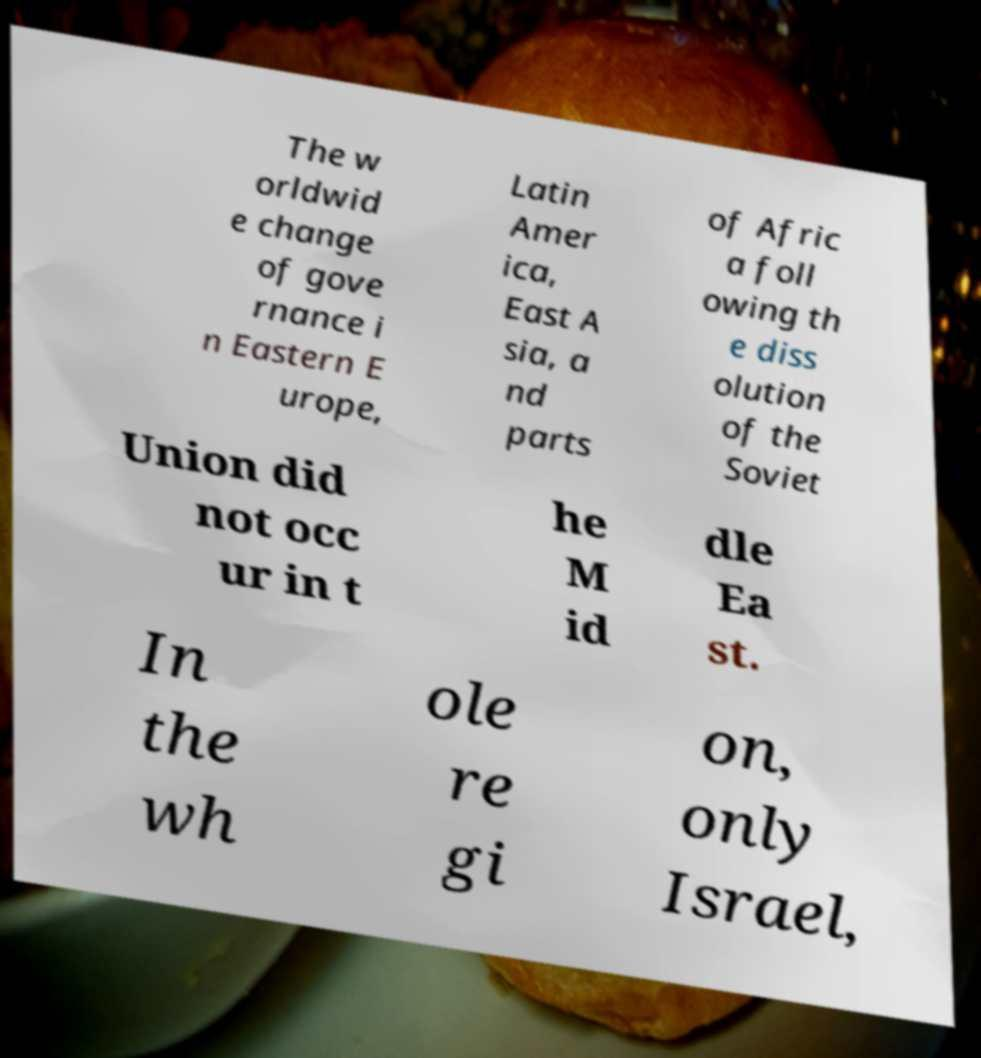Could you assist in decoding the text presented in this image and type it out clearly? The w orldwid e change of gove rnance i n Eastern E urope, Latin Amer ica, East A sia, a nd parts of Afric a foll owing th e diss olution of the Soviet Union did not occ ur in t he M id dle Ea st. In the wh ole re gi on, only Israel, 